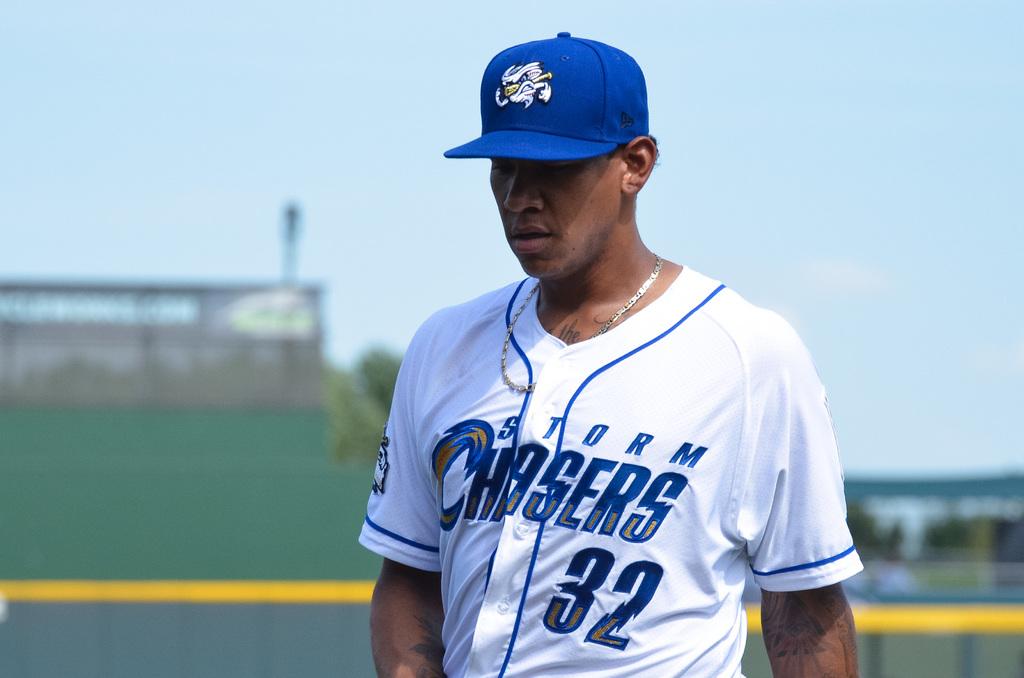What is the team this player plays for?
Ensure brevity in your answer.  Storm chasers. What number is on the jersey?
Provide a short and direct response. 32. 